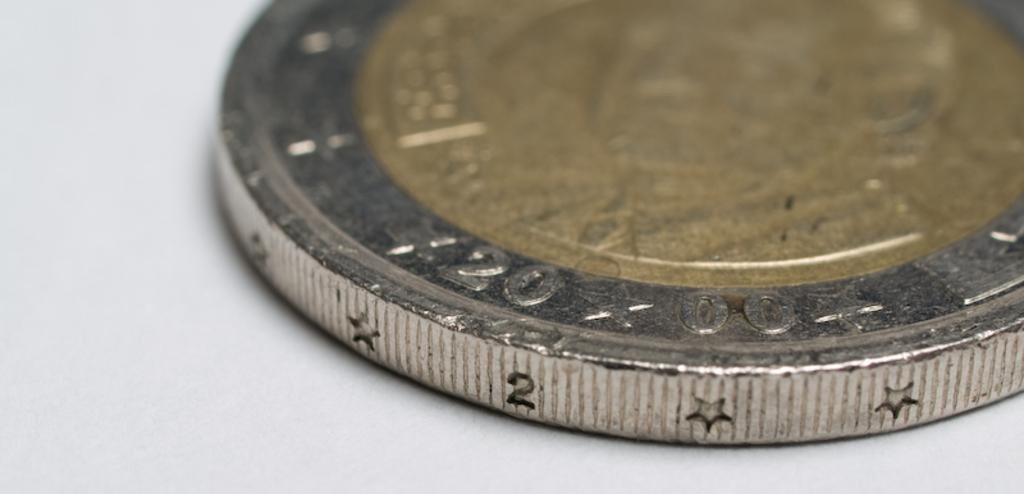<image>
Summarize the visual content of the image. The number 20 can be seen on the side of a coin. 